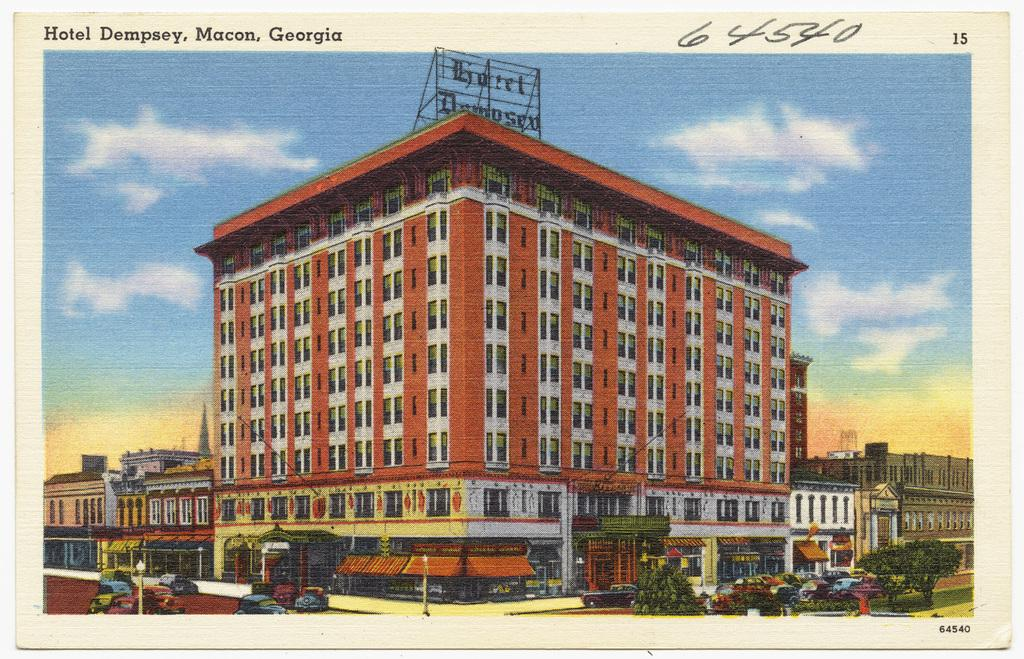What type of structures can be seen in the image? There are buildings in the image. What else is visible in the image besides buildings? There are cars and trees in the image. Where is the text located in the image? The text is in the top left of the image. What is visible at the top of the image? The sky is visible at the top of the image. How does the image change when you apply a stamp to it? The image does not change when you apply a stamp to it, as the question refers to an action that is not present in the image. 